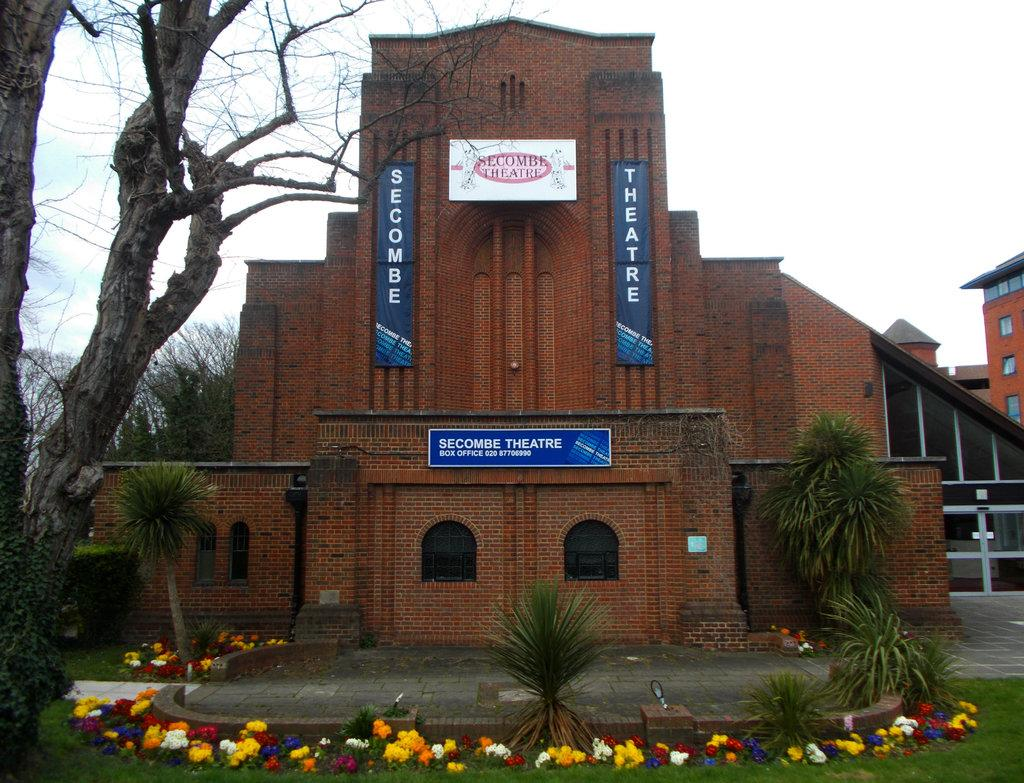What type of vegetation is present at the bottom of the image? There are flowers and plants at the bottom of the image. What can be seen on the building in the image? There are boards on a building in the image. What is located on the left side of the image? There are trees on the left side of the image. What is visible at the top of the image? The sky is visible at the top of the image. Can you tell me how many cats are sitting on the boards in the image? There are no cats present in the image; it features flowers, plants, trees, and a building with boards. What type of riddle is written on the boards in the image? There is no riddle written on the boards in the image; they are just plain boards on a building. 